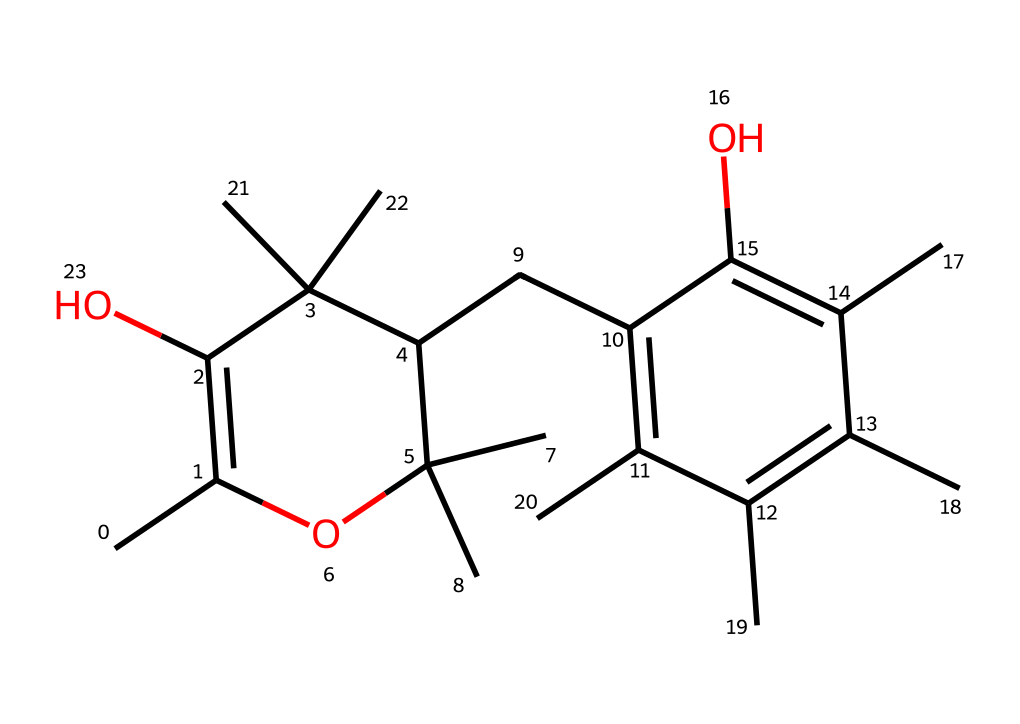What is the main functional group present in this molecule? The chemical contains multiple hydroxyl groups (-OH) attached to its carbon skeleton, which are indicative of alcohols, making these groups the main functional group.
Answer: hydroxyl How many carbon atoms are in this structure? By analyzing the SMILES, we can count the number of 'C' representations, which shows a total of 20 carbon atoms in this structure.
Answer: 20 What type of vitamin is represented by this structure? The structure closely resembles that of Vitamin E, which is a fat-soluble vitamin known for its antioxidant properties.
Answer: Vitamin E Does this molecule contain any double bonds? The SMILES notation includes several "=" symbols, indicating that there are double bonds present in this chemical structure.
Answer: yes How would the presence of hydroxyl groups influence the solubility of this vitamin? The hydroxyl groups increase the polarity of the molecule, which often enhances its solubility in polar solvents such as water, although Vitamin E is generally considered lipophilic due to its overall structure.
Answer: increases solubility What is the total number of rings present in the chemical structure? By examining the cyclic structure represented in the SMILES, we can see that there are 2 distinct rings involving carbon atoms that form part of the overall molecule.
Answer: 2 How does the structural complexity of Vitamin E relate to its role in environmental policy discussions? Given the intricate structure of Vitamin E, as seen in the presence of multiple functional groups and rings, this complexity is significant in discussions of bioaccumulation and the impact of synthetic chemicals on ecosystems.
Answer: structural complexity 